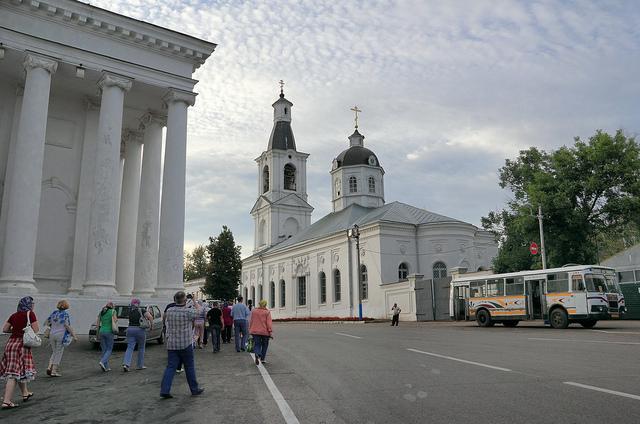What is the clock tower made of?
Short answer required. Concrete. Is that a clock on the side of the steeple?
Answer briefly. No. What lines are on the road?
Quick response, please. White. Is this a cobblestone street?
Be succinct. No. What color is the bus?
Keep it brief. White. Is there a clock on the tower?
Answer briefly. No. Is the pic black and white?
Quick response, please. No. Is there a clock?
Short answer required. No. What style of architecture does this structure embody?
Write a very short answer. Greek. What is the most prominent color in this picture?
Short answer required. White. What kind of weather is present in the scene?
Be succinct. Cloudy. Are all the vehicles buses?
Answer briefly. No. What color is the first vehicle in line on the right?
Quick response, please. White. What is the purpose for the front building?
Write a very short answer. Church. Is this a church?
Answer briefly. Yes. Are there people in the picture?
Keep it brief. Yes. Are they gather for a skateboard practice?
Quick response, please. No. Is the street wet with rain?
Give a very brief answer. No. Is this a current photo?
Quick response, please. Yes. Has the street recently been paved?
Keep it brief. No. Are there clocks in the tower?
Concise answer only. No. How many people are in a red shirt?
Write a very short answer. 2. What color is the building on the left?
Be succinct. White. What color are the buildings?
Be succinct. White. What type of tree is on the right?
Be succinct. Elm. How many people are present?
Concise answer only. 12. Is this a tower clock?
Be succinct. No. Is this church open?
Answer briefly. Yes. What era was this photo taken?
Write a very short answer. Modern. Is this in a foreign country?
Answer briefly. Yes. What color is the building?
Quick response, please. White. Does the building have a lot of windows?
Quick response, please. Yes. 